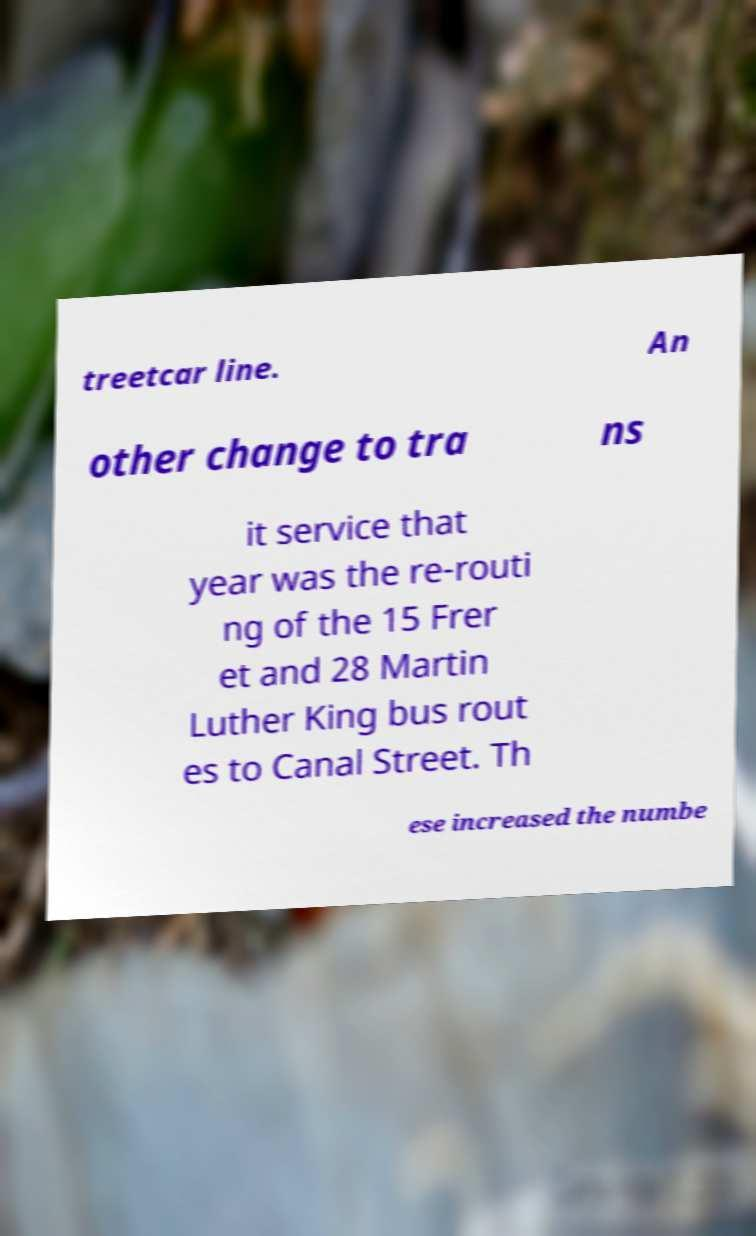Could you assist in decoding the text presented in this image and type it out clearly? treetcar line. An other change to tra ns it service that year was the re-routi ng of the 15 Frer et and 28 Martin Luther King bus rout es to Canal Street. Th ese increased the numbe 